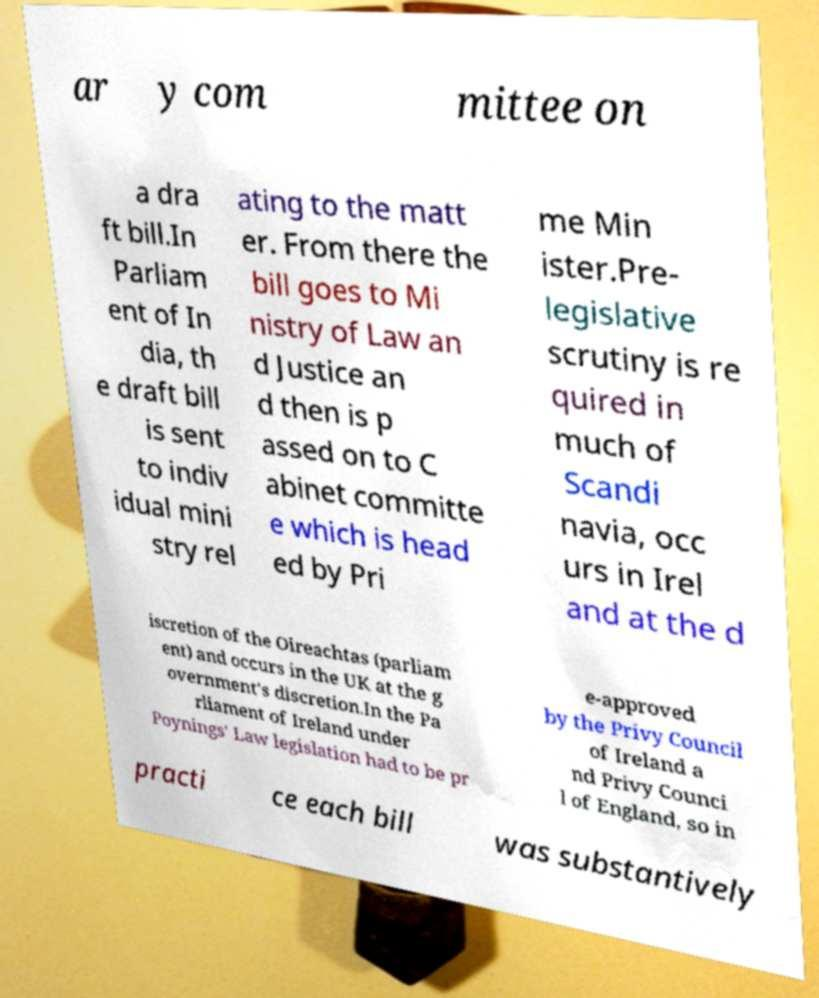Please read and relay the text visible in this image. What does it say? ar y com mittee on a dra ft bill.In Parliam ent of In dia, th e draft bill is sent to indiv idual mini stry rel ating to the matt er. From there the bill goes to Mi nistry of Law an d Justice an d then is p assed on to C abinet committe e which is head ed by Pri me Min ister.Pre- legislative scrutiny is re quired in much of Scandi navia, occ urs in Irel and at the d iscretion of the Oireachtas (parliam ent) and occurs in the UK at the g overnment's discretion.In the Pa rliament of Ireland under Poynings' Law legislation had to be pr e-approved by the Privy Council of Ireland a nd Privy Counci l of England, so in practi ce each bill was substantively 